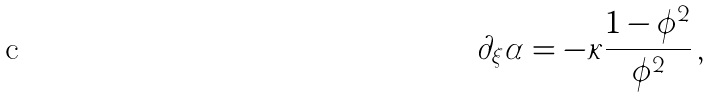<formula> <loc_0><loc_0><loc_500><loc_500>\partial _ { \xi } \alpha = - \kappa \frac { 1 - \phi ^ { 2 } } { \phi ^ { 2 } } \, ,</formula> 